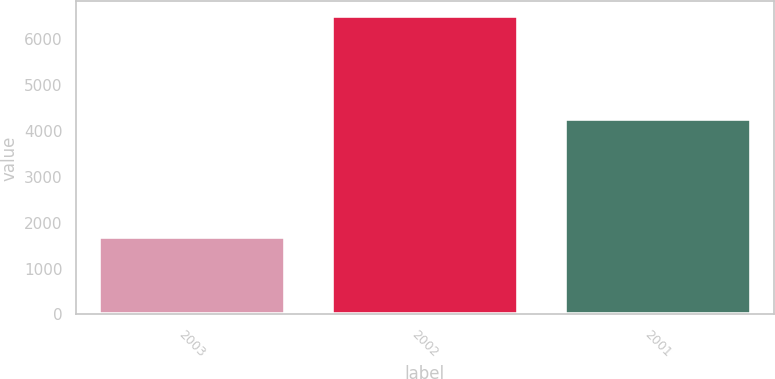<chart> <loc_0><loc_0><loc_500><loc_500><bar_chart><fcel>2003<fcel>2002<fcel>2001<nl><fcel>1693<fcel>6504<fcel>4271<nl></chart> 